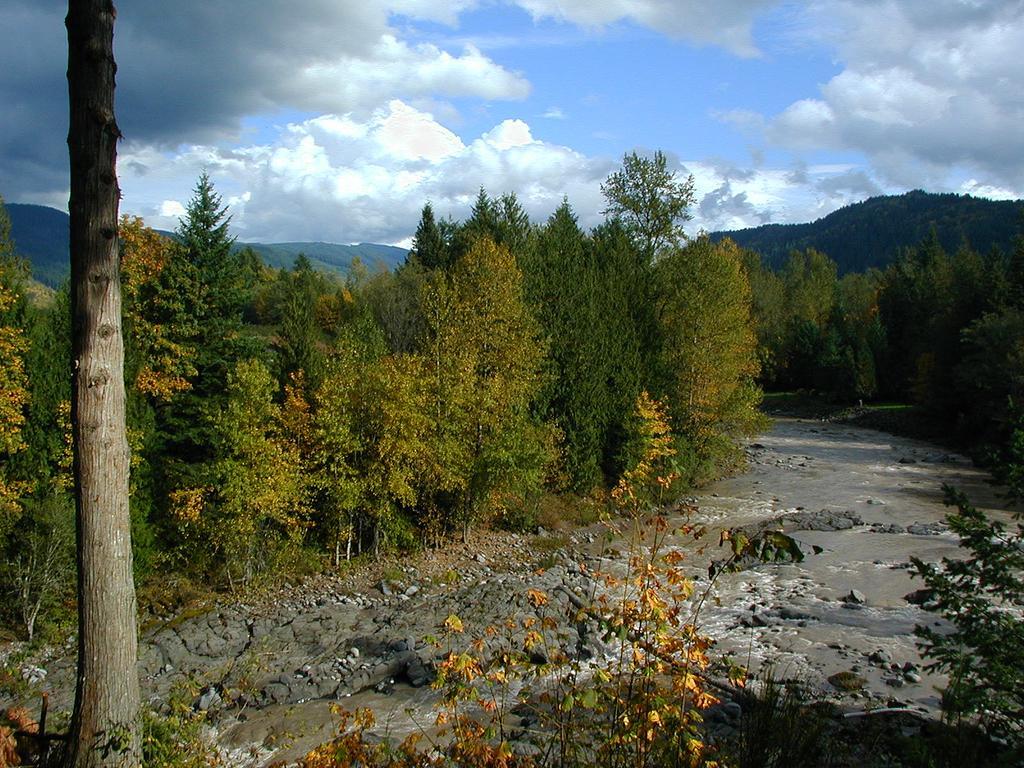In one or two sentences, can you explain what this image depicts? At the bottom of the image there are stones,trees,water. In the background of the image there are mountains, sky, trees. To the left side of the image there is a tree trunk. 